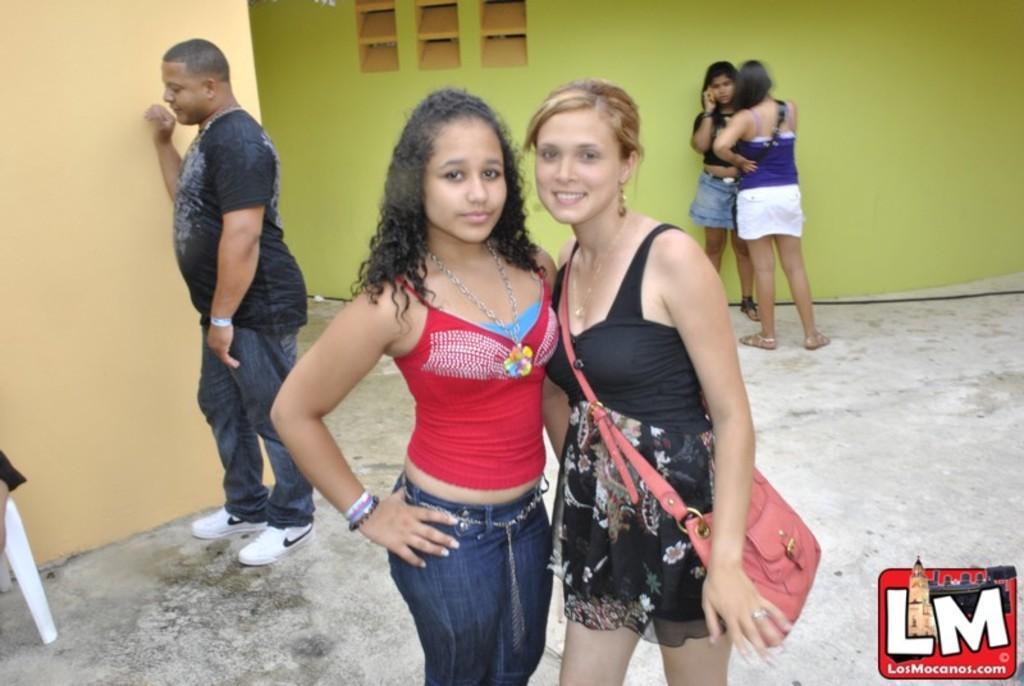Can you describe this image briefly? In this image we can see two women standing. On the backside we can see a person on a chair and some people standing beside the walls. 